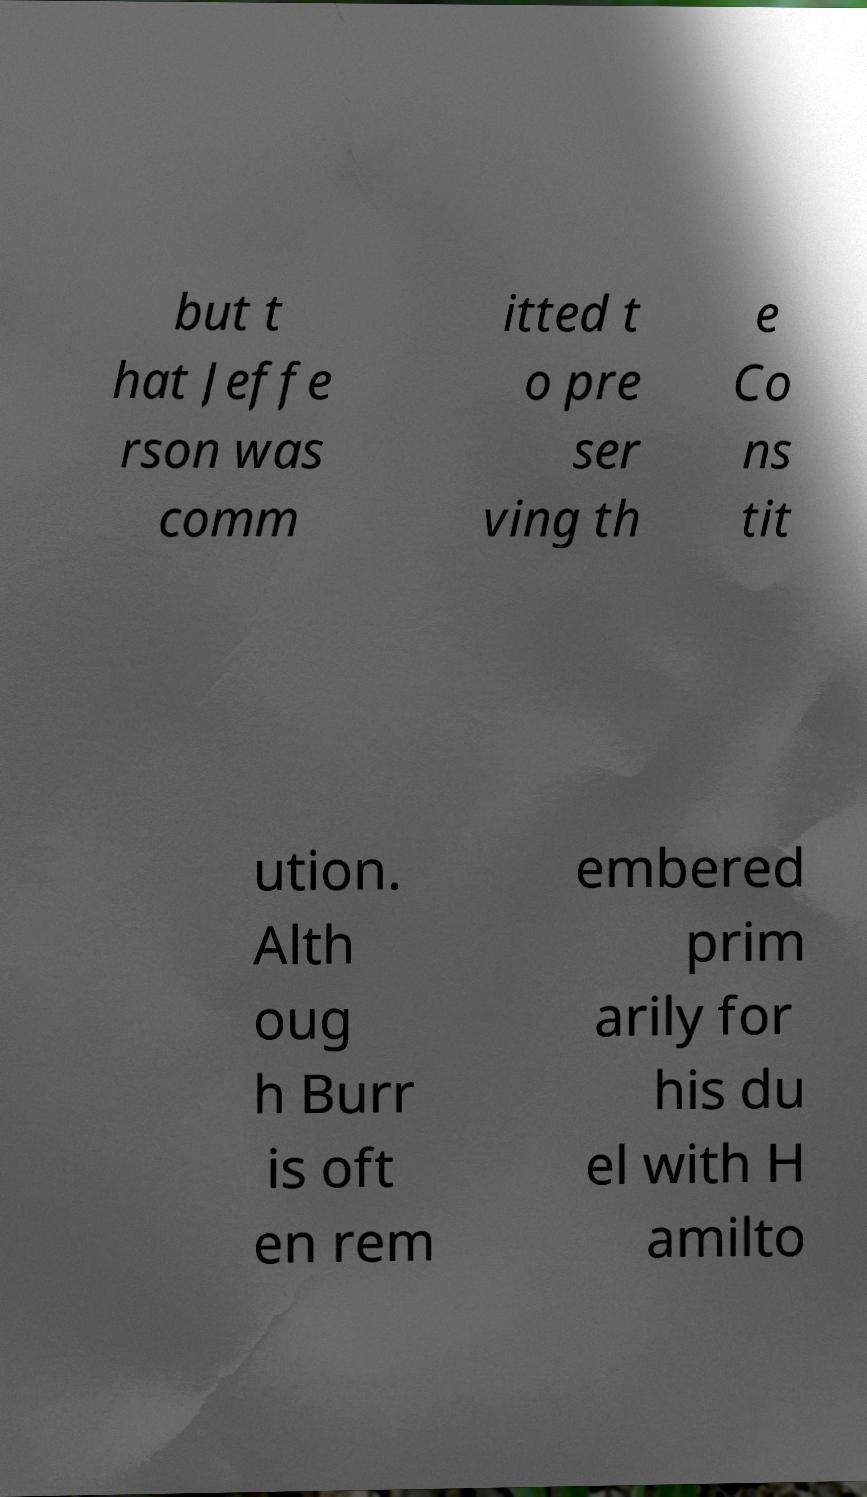Can you accurately transcribe the text from the provided image for me? but t hat Jeffe rson was comm itted t o pre ser ving th e Co ns tit ution. Alth oug h Burr is oft en rem embered prim arily for his du el with H amilto 